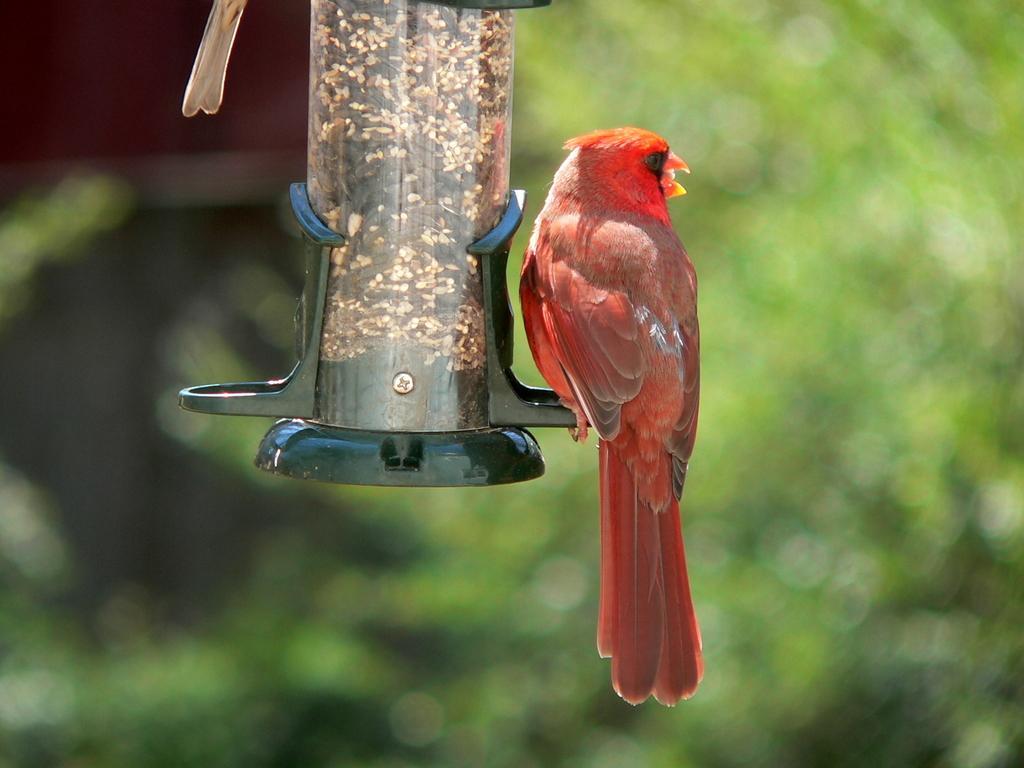Could you give a brief overview of what you see in this image? In this image we can see a bird feeder stock and one red color bird. 